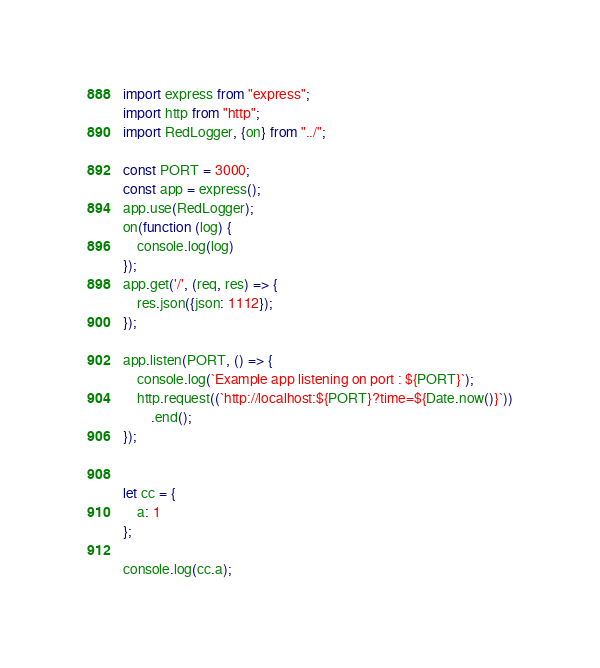<code> <loc_0><loc_0><loc_500><loc_500><_JavaScript_>import express from "express";
import http from "http";
import RedLogger, {on} from "../";

const PORT = 3000;
const app = express();
app.use(RedLogger);
on(function (log) {
	console.log(log)
});
app.get('/', (req, res) => {
	res.json({json: 1112});
});

app.listen(PORT, () => {
	console.log(`Example app listening on port : ${PORT}`);
	http.request((`http://localhost:${PORT}?time=${Date.now()}`))
		.end();
});


let cc = {
	a: 1
};

console.log(cc.a);
</code> 